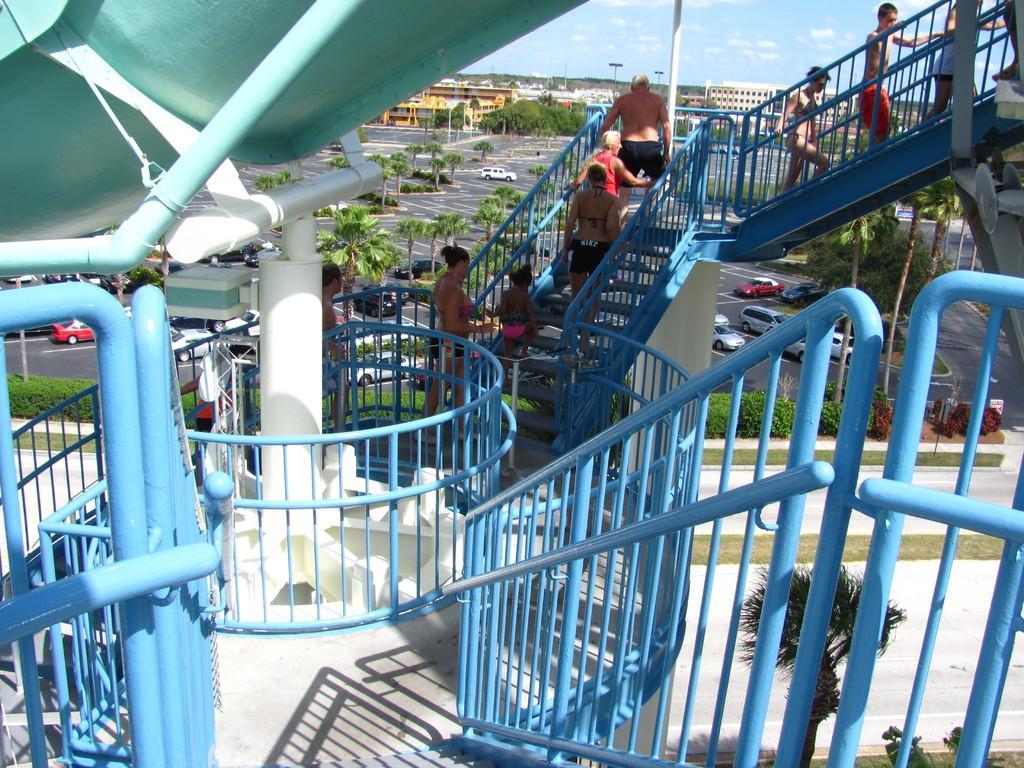How would you summarize this image in a sentence or two? In this picture I can see the blue railings and I see few people on the steps and I see the blue color thing on the left top. In the middle of this image I see the plants, trees, cars and number of buildings. In the background I see the sky. 